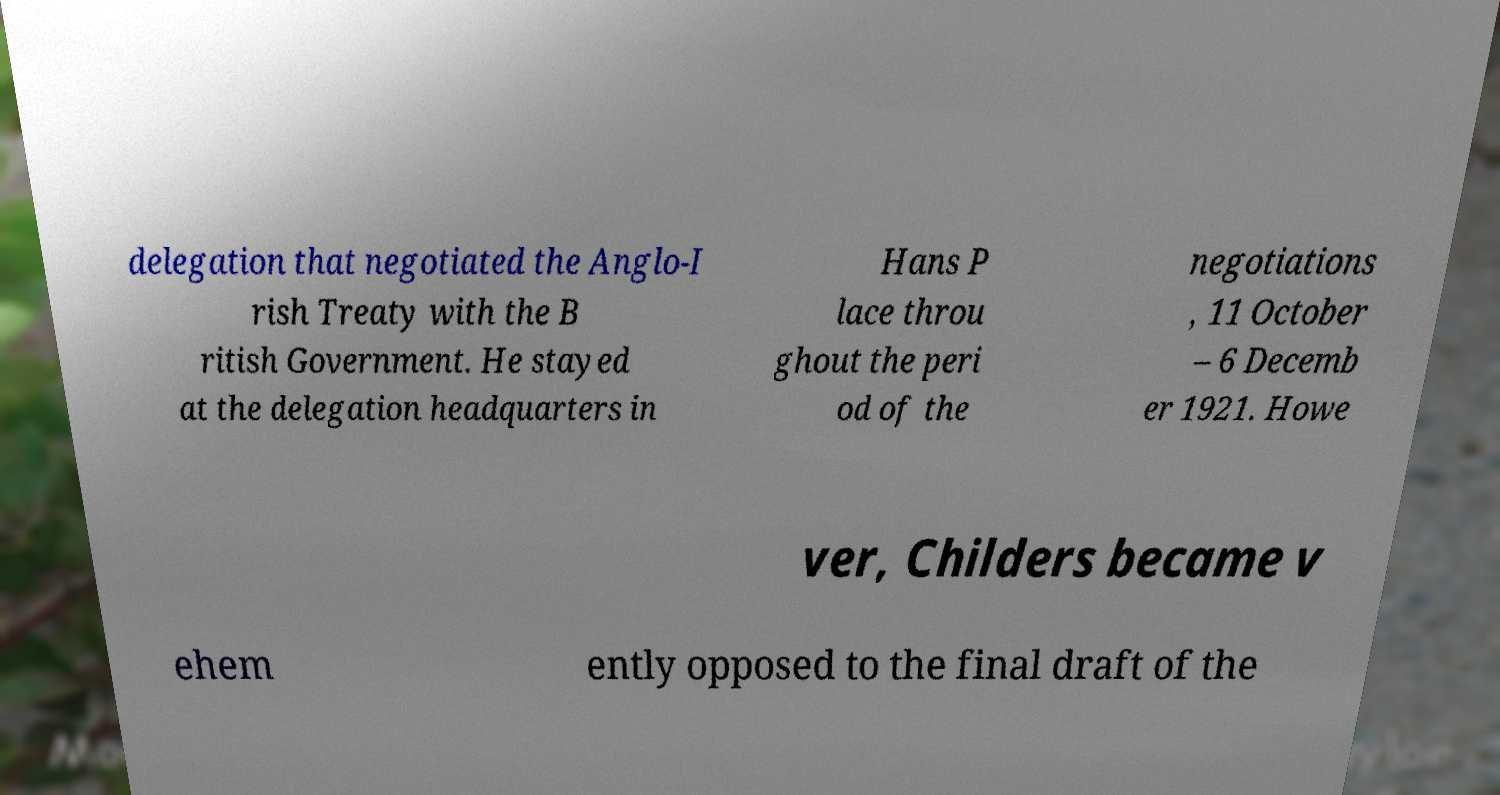I need the written content from this picture converted into text. Can you do that? delegation that negotiated the Anglo-I rish Treaty with the B ritish Government. He stayed at the delegation headquarters in Hans P lace throu ghout the peri od of the negotiations , 11 October – 6 Decemb er 1921. Howe ver, Childers became v ehem ently opposed to the final draft of the 